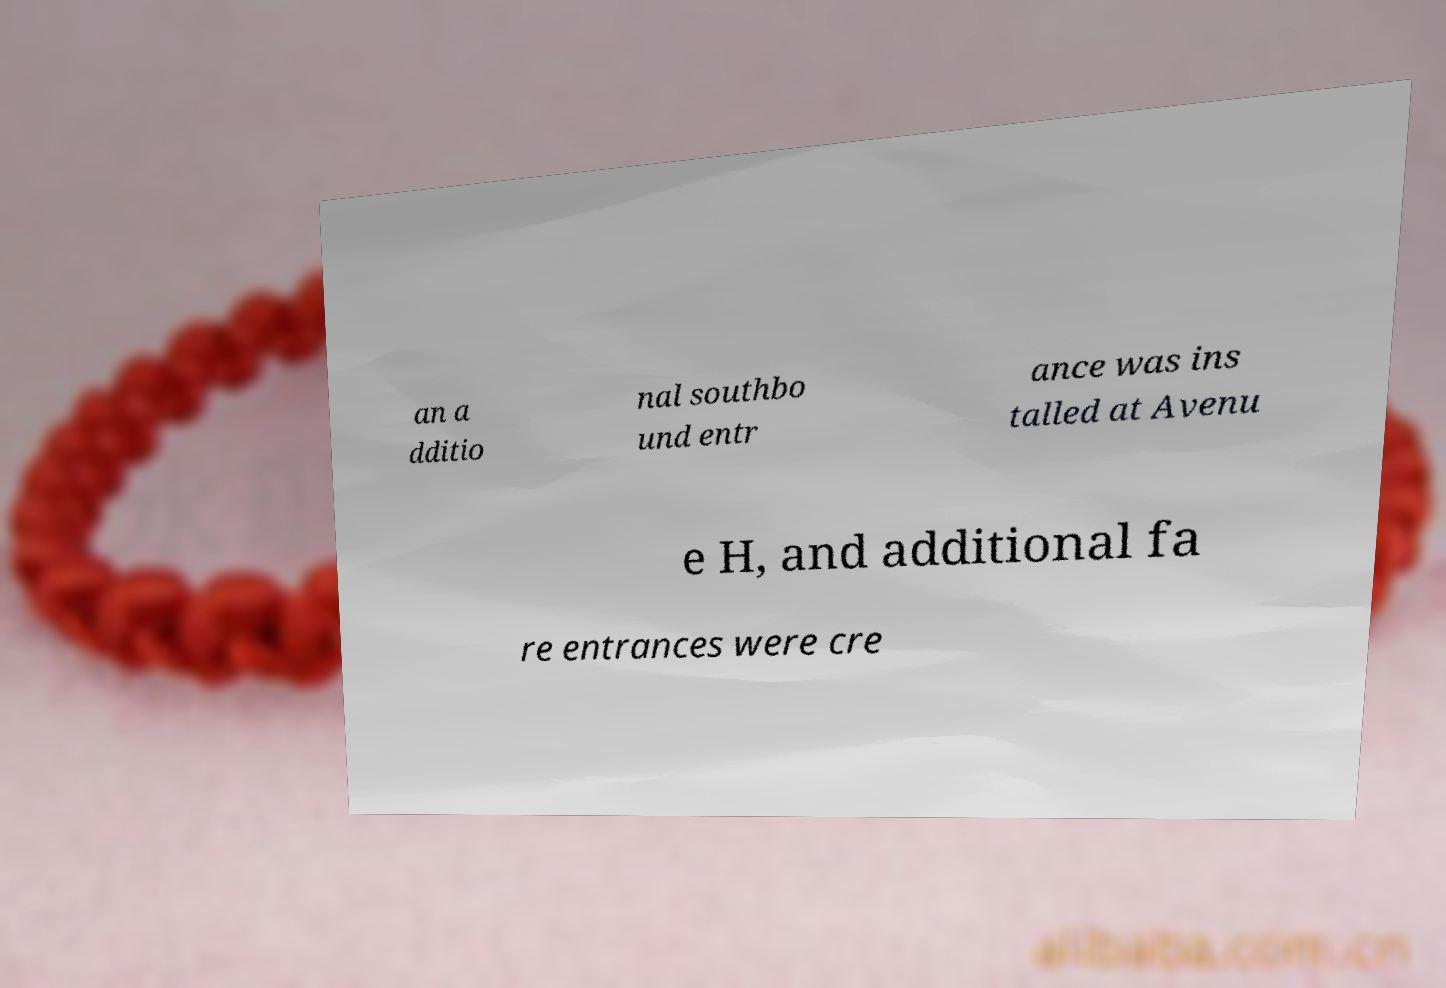What messages or text are displayed in this image? I need them in a readable, typed format. an a dditio nal southbo und entr ance was ins talled at Avenu e H, and additional fa re entrances were cre 